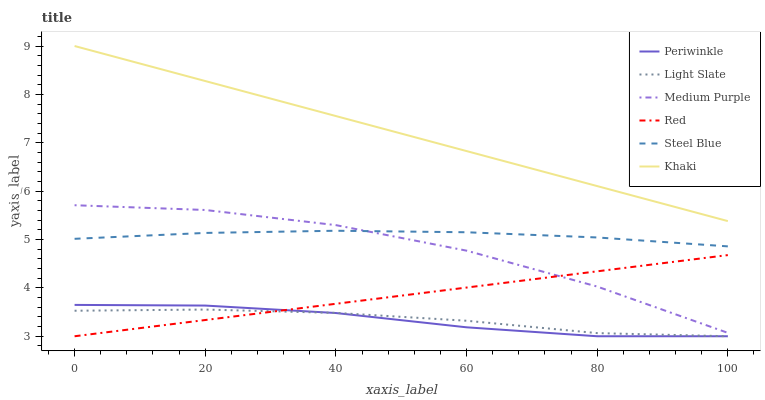Does Periwinkle have the minimum area under the curve?
Answer yes or no. Yes. Does Khaki have the maximum area under the curve?
Answer yes or no. Yes. Does Light Slate have the minimum area under the curve?
Answer yes or no. No. Does Light Slate have the maximum area under the curve?
Answer yes or no. No. Is Red the smoothest?
Answer yes or no. Yes. Is Medium Purple the roughest?
Answer yes or no. Yes. Is Light Slate the smoothest?
Answer yes or no. No. Is Light Slate the roughest?
Answer yes or no. No. Does Light Slate have the lowest value?
Answer yes or no. Yes. Does Steel Blue have the lowest value?
Answer yes or no. No. Does Khaki have the highest value?
Answer yes or no. Yes. Does Steel Blue have the highest value?
Answer yes or no. No. Is Red less than Steel Blue?
Answer yes or no. Yes. Is Khaki greater than Light Slate?
Answer yes or no. Yes. Does Medium Purple intersect Steel Blue?
Answer yes or no. Yes. Is Medium Purple less than Steel Blue?
Answer yes or no. No. Is Medium Purple greater than Steel Blue?
Answer yes or no. No. Does Red intersect Steel Blue?
Answer yes or no. No. 